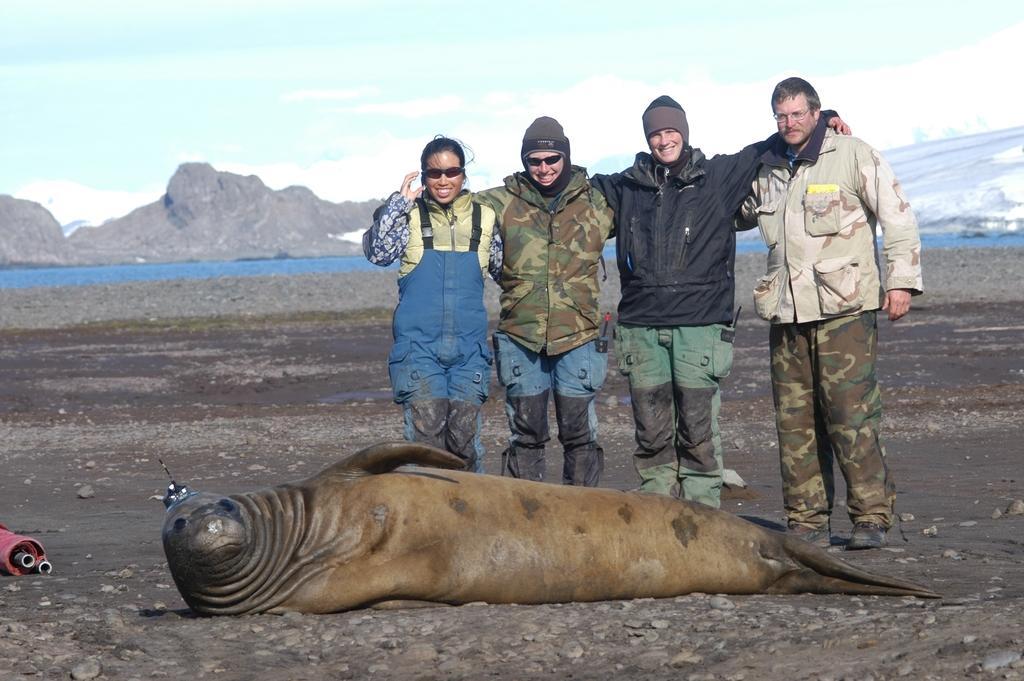Can you describe this image briefly? In this image there are four people standing, and two of them are wearing goggles and two of them are wearing caps. And in the center there is seal, at the bottom there is walkway and in the background there is a river and some mountains and snow. At the top there is sky, and on the left side of the image there are some objects. 